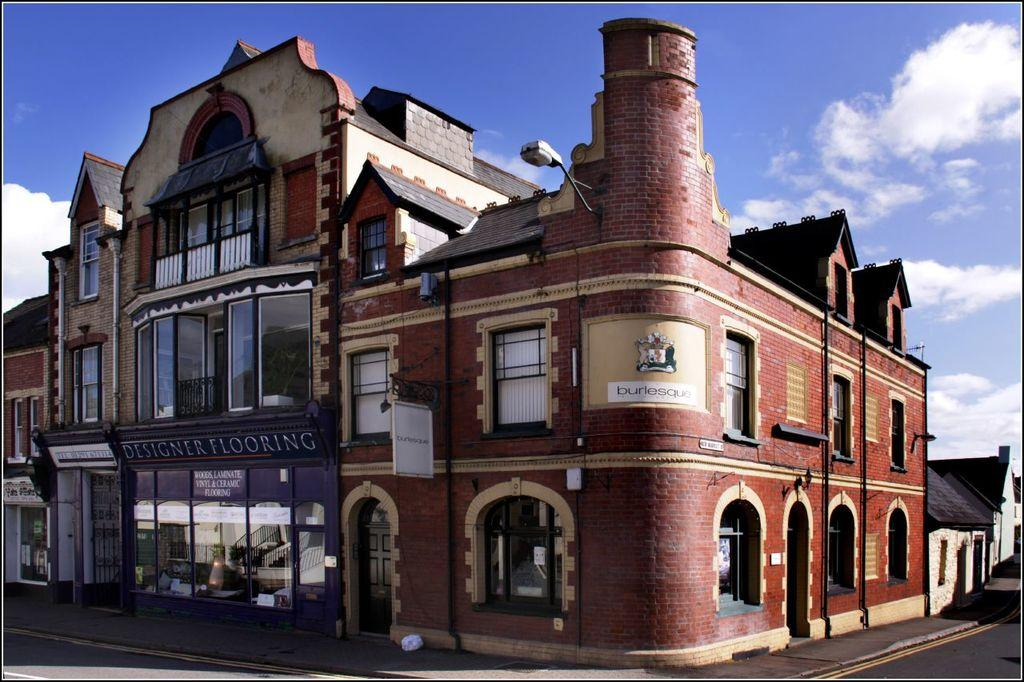What is located at the bottom of the image? There is a road and a footpath at the bottom of the image. What can be seen in the background of the image? There are buildings and clouds in the sky in the background of the image. What flavor of liquid is being poured from the clouds in the image? There is no liquid being poured from the clouds in the image; it only shows clouds in the sky. What type of haircut is visible on the buildings in the image? The buildings in the image do not have haircuts, as they are inanimate structures. 